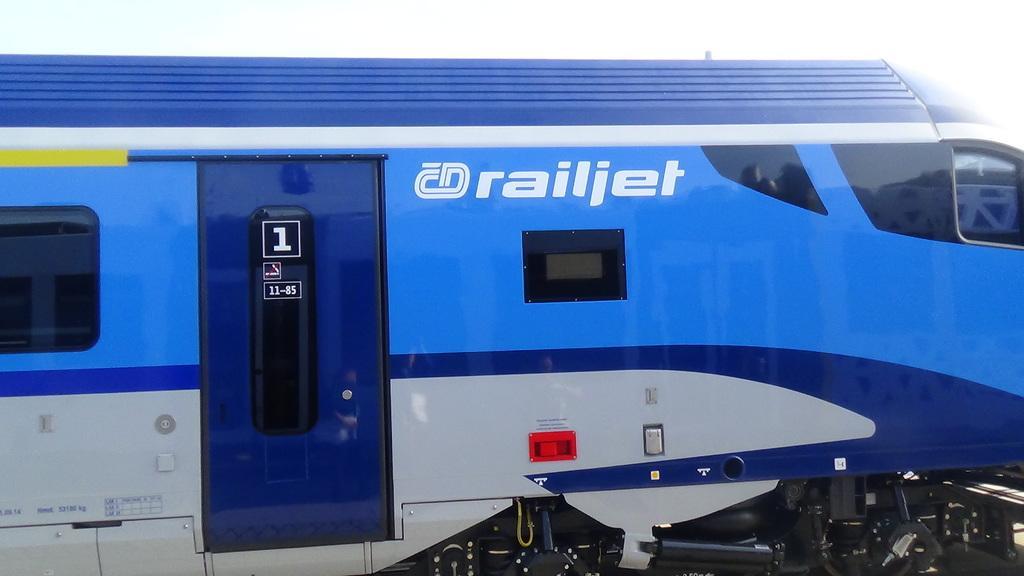Please provide a concise description of this image. In this picture there is a blue train which has something written on it. 